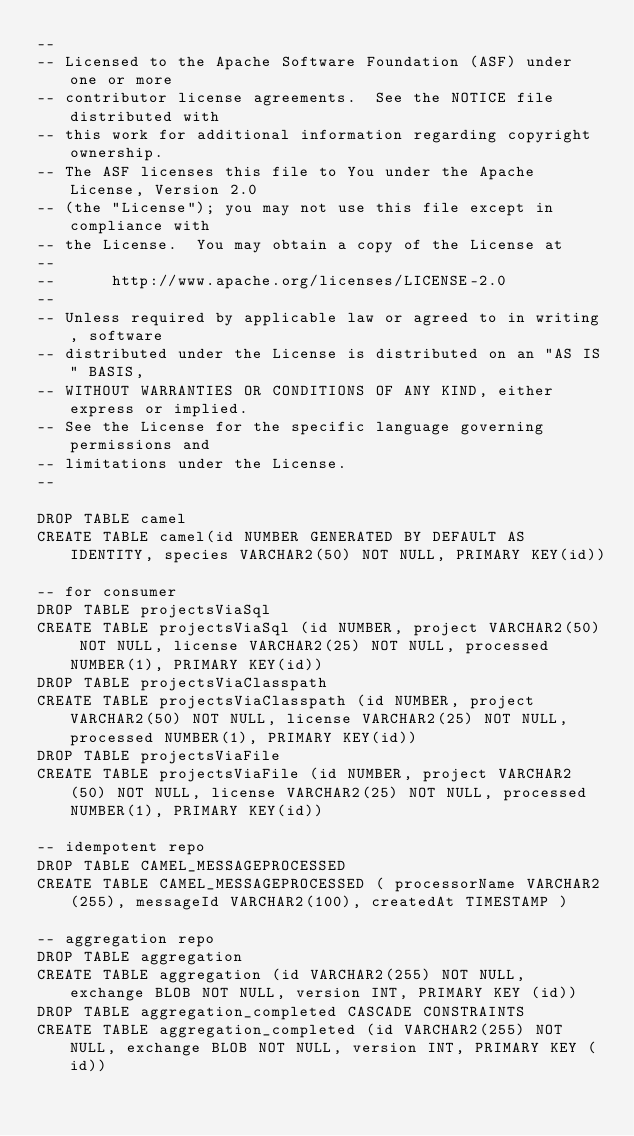Convert code to text. <code><loc_0><loc_0><loc_500><loc_500><_SQL_>--
-- Licensed to the Apache Software Foundation (ASF) under one or more
-- contributor license agreements.  See the NOTICE file distributed with
-- this work for additional information regarding copyright ownership.
-- The ASF licenses this file to You under the Apache License, Version 2.0
-- (the "License"); you may not use this file except in compliance with
-- the License.  You may obtain a copy of the License at
--
--      http://www.apache.org/licenses/LICENSE-2.0
--
-- Unless required by applicable law or agreed to in writing, software
-- distributed under the License is distributed on an "AS IS" BASIS,
-- WITHOUT WARRANTIES OR CONDITIONS OF ANY KIND, either express or implied.
-- See the License for the specific language governing permissions and
-- limitations under the License.
--

DROP TABLE camel
CREATE TABLE camel(id NUMBER GENERATED BY DEFAULT AS IDENTITY, species VARCHAR2(50) NOT NULL, PRIMARY KEY(id))

-- for consumer
DROP TABLE projectsViaSql
CREATE TABLE projectsViaSql (id NUMBER, project VARCHAR2(50) NOT NULL, license VARCHAR2(25) NOT NULL, processed NUMBER(1), PRIMARY KEY(id))
DROP TABLE projectsViaClasspath
CREATE TABLE projectsViaClasspath (id NUMBER, project VARCHAR2(50) NOT NULL, license VARCHAR2(25) NOT NULL, processed NUMBER(1), PRIMARY KEY(id))
DROP TABLE projectsViaFile
CREATE TABLE projectsViaFile (id NUMBER, project VARCHAR2(50) NOT NULL, license VARCHAR2(25) NOT NULL, processed NUMBER(1), PRIMARY KEY(id))

-- idempotent repo
DROP TABLE CAMEL_MESSAGEPROCESSED
CREATE TABLE CAMEL_MESSAGEPROCESSED ( processorName VARCHAR2(255), messageId VARCHAR2(100), createdAt TIMESTAMP )

-- aggregation repo
DROP TABLE aggregation
CREATE TABLE aggregation (id VARCHAR2(255) NOT NULL, exchange BLOB NOT NULL, version INT, PRIMARY KEY (id))
DROP TABLE aggregation_completed CASCADE CONSTRAINTS
CREATE TABLE aggregation_completed (id VARCHAR2(255) NOT NULL, exchange BLOB NOT NULL, version INT, PRIMARY KEY (id))
</code> 